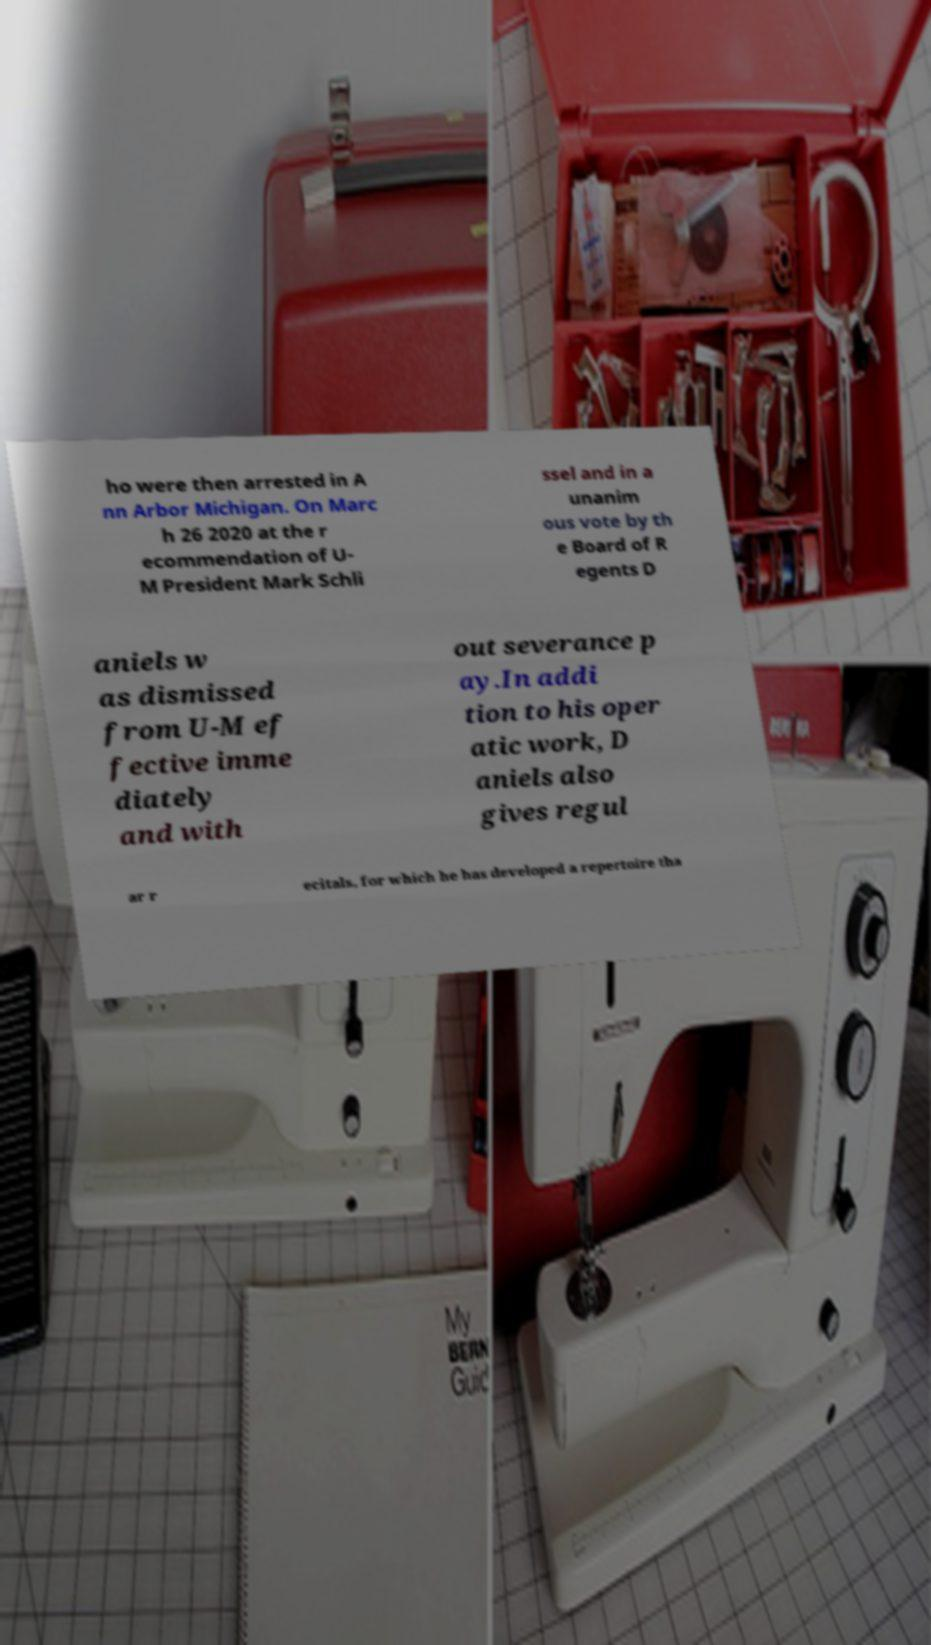I need the written content from this picture converted into text. Can you do that? ho were then arrested in A nn Arbor Michigan. On Marc h 26 2020 at the r ecommendation of U- M President Mark Schli ssel and in a unanim ous vote by th e Board of R egents D aniels w as dismissed from U-M ef fective imme diately and with out severance p ay.In addi tion to his oper atic work, D aniels also gives regul ar r ecitals, for which he has developed a repertoire tha 